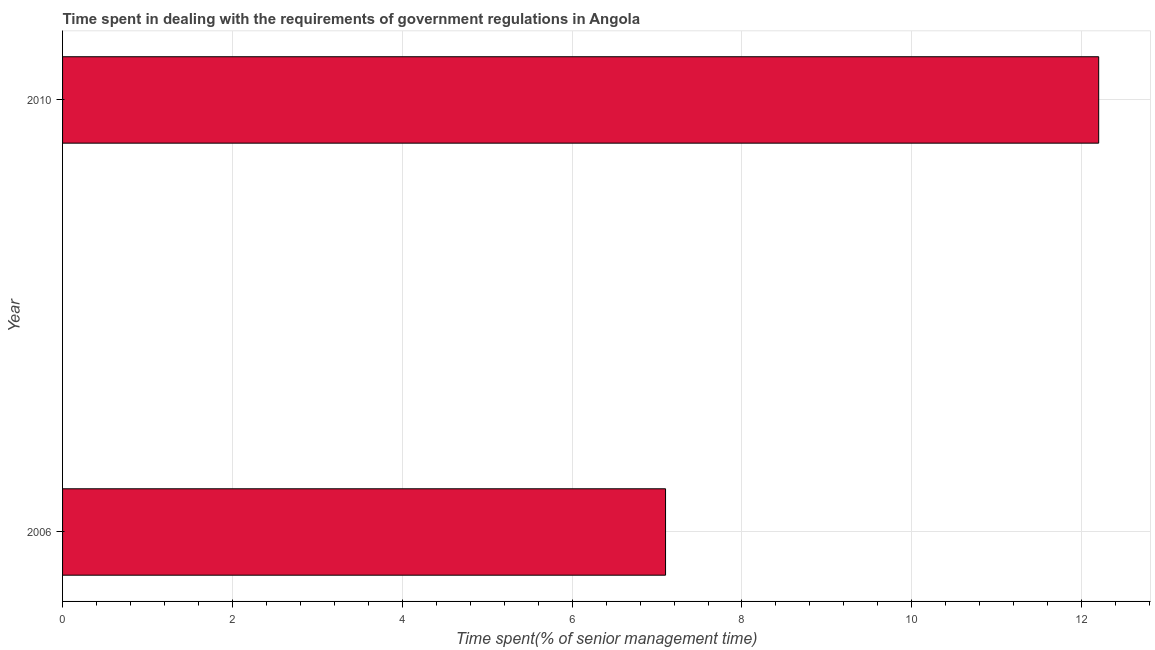Does the graph contain any zero values?
Your response must be concise. No. Does the graph contain grids?
Your response must be concise. Yes. What is the title of the graph?
Offer a very short reply. Time spent in dealing with the requirements of government regulations in Angola. What is the label or title of the X-axis?
Your answer should be compact. Time spent(% of senior management time). What is the time spent in dealing with government regulations in 2006?
Offer a terse response. 7.1. Across all years, what is the maximum time spent in dealing with government regulations?
Give a very brief answer. 12.2. Across all years, what is the minimum time spent in dealing with government regulations?
Give a very brief answer. 7.1. In which year was the time spent in dealing with government regulations minimum?
Your answer should be very brief. 2006. What is the sum of the time spent in dealing with government regulations?
Give a very brief answer. 19.3. What is the difference between the time spent in dealing with government regulations in 2006 and 2010?
Provide a short and direct response. -5.1. What is the average time spent in dealing with government regulations per year?
Give a very brief answer. 9.65. What is the median time spent in dealing with government regulations?
Give a very brief answer. 9.65. In how many years, is the time spent in dealing with government regulations greater than 5.6 %?
Ensure brevity in your answer.  2. Do a majority of the years between 2006 and 2010 (inclusive) have time spent in dealing with government regulations greater than 9.2 %?
Offer a terse response. No. What is the ratio of the time spent in dealing with government regulations in 2006 to that in 2010?
Provide a short and direct response. 0.58. In how many years, is the time spent in dealing with government regulations greater than the average time spent in dealing with government regulations taken over all years?
Give a very brief answer. 1. How many bars are there?
Your answer should be very brief. 2. Are all the bars in the graph horizontal?
Provide a succinct answer. Yes. How many years are there in the graph?
Provide a short and direct response. 2. What is the difference between two consecutive major ticks on the X-axis?
Offer a terse response. 2. What is the Time spent(% of senior management time) in 2006?
Ensure brevity in your answer.  7.1. What is the Time spent(% of senior management time) in 2010?
Give a very brief answer. 12.2. What is the ratio of the Time spent(% of senior management time) in 2006 to that in 2010?
Offer a very short reply. 0.58. 